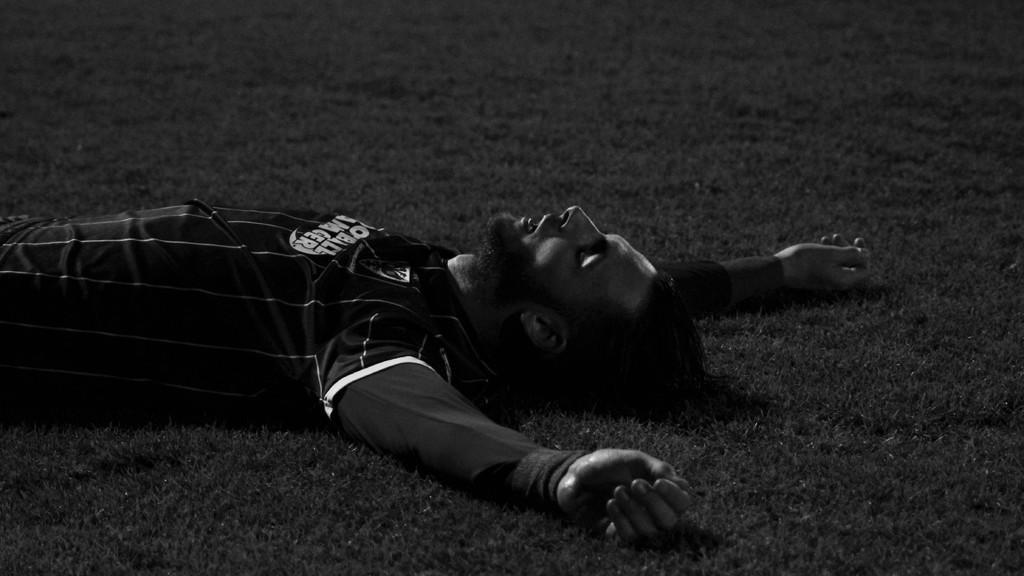In one or two sentences, can you explain what this image depicts? In this image I can see the black and white picture in which I can see a person is wearing black color dress is laying on the ground. 